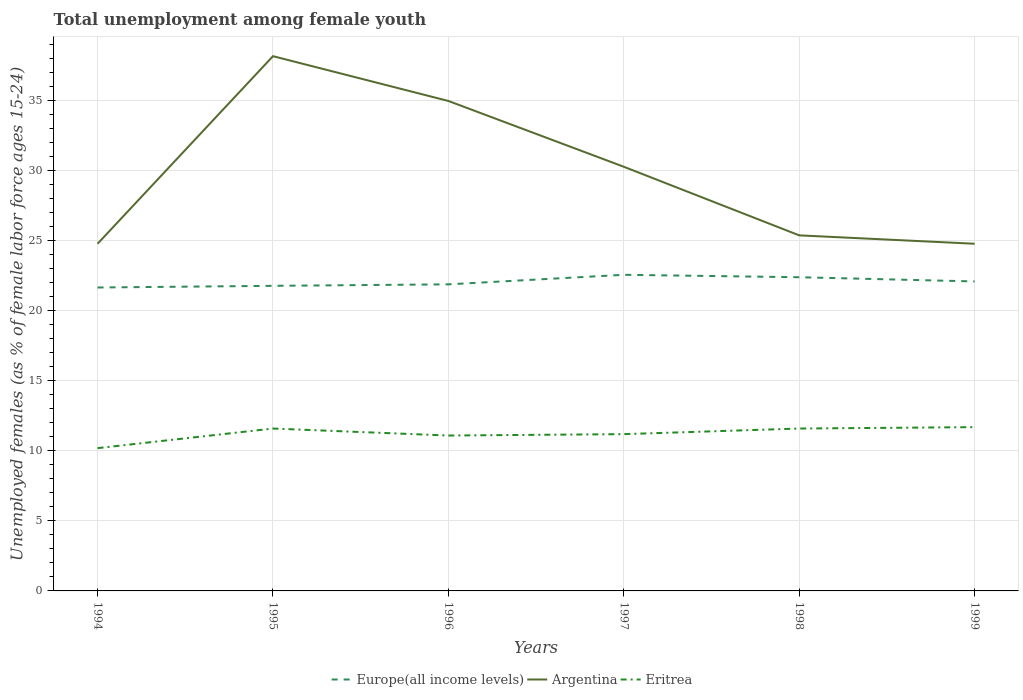Does the line corresponding to Europe(all income levels) intersect with the line corresponding to Eritrea?
Provide a succinct answer. No. Is the number of lines equal to the number of legend labels?
Offer a terse response. Yes. Across all years, what is the maximum percentage of unemployed females in in Europe(all income levels)?
Offer a terse response. 21.68. In which year was the percentage of unemployed females in in Eritrea maximum?
Provide a succinct answer. 1994. What is the total percentage of unemployed females in in Europe(all income levels) in the graph?
Give a very brief answer. -0.31. What is the difference between the highest and the second highest percentage of unemployed females in in Argentina?
Give a very brief answer. 13.4. Is the percentage of unemployed females in in Argentina strictly greater than the percentage of unemployed females in in Eritrea over the years?
Your answer should be compact. No. How many lines are there?
Offer a very short reply. 3. Are the values on the major ticks of Y-axis written in scientific E-notation?
Your response must be concise. No. Does the graph contain any zero values?
Your response must be concise. No. How are the legend labels stacked?
Your answer should be very brief. Horizontal. What is the title of the graph?
Provide a short and direct response. Total unemployment among female youth. What is the label or title of the Y-axis?
Offer a terse response. Unemployed females (as % of female labor force ages 15-24). What is the Unemployed females (as % of female labor force ages 15-24) of Europe(all income levels) in 1994?
Provide a succinct answer. 21.68. What is the Unemployed females (as % of female labor force ages 15-24) in Argentina in 1994?
Your answer should be very brief. 24.8. What is the Unemployed females (as % of female labor force ages 15-24) in Eritrea in 1994?
Provide a succinct answer. 10.2. What is the Unemployed females (as % of female labor force ages 15-24) of Europe(all income levels) in 1995?
Keep it short and to the point. 21.79. What is the Unemployed females (as % of female labor force ages 15-24) of Argentina in 1995?
Your answer should be very brief. 38.2. What is the Unemployed females (as % of female labor force ages 15-24) of Eritrea in 1995?
Keep it short and to the point. 11.6. What is the Unemployed females (as % of female labor force ages 15-24) of Europe(all income levels) in 1996?
Make the answer very short. 21.9. What is the Unemployed females (as % of female labor force ages 15-24) of Eritrea in 1996?
Provide a short and direct response. 11.1. What is the Unemployed females (as % of female labor force ages 15-24) of Europe(all income levels) in 1997?
Your answer should be compact. 22.58. What is the Unemployed females (as % of female labor force ages 15-24) in Argentina in 1997?
Make the answer very short. 30.3. What is the Unemployed females (as % of female labor force ages 15-24) in Eritrea in 1997?
Your answer should be compact. 11.2. What is the Unemployed females (as % of female labor force ages 15-24) of Europe(all income levels) in 1998?
Your answer should be very brief. 22.41. What is the Unemployed females (as % of female labor force ages 15-24) of Argentina in 1998?
Provide a succinct answer. 25.4. What is the Unemployed females (as % of female labor force ages 15-24) in Eritrea in 1998?
Keep it short and to the point. 11.6. What is the Unemployed females (as % of female labor force ages 15-24) of Europe(all income levels) in 1999?
Provide a short and direct response. 22.11. What is the Unemployed females (as % of female labor force ages 15-24) in Argentina in 1999?
Your answer should be compact. 24.8. What is the Unemployed females (as % of female labor force ages 15-24) of Eritrea in 1999?
Give a very brief answer. 11.7. Across all years, what is the maximum Unemployed females (as % of female labor force ages 15-24) in Europe(all income levels)?
Provide a succinct answer. 22.58. Across all years, what is the maximum Unemployed females (as % of female labor force ages 15-24) of Argentina?
Your answer should be compact. 38.2. Across all years, what is the maximum Unemployed females (as % of female labor force ages 15-24) of Eritrea?
Make the answer very short. 11.7. Across all years, what is the minimum Unemployed females (as % of female labor force ages 15-24) of Europe(all income levels)?
Keep it short and to the point. 21.68. Across all years, what is the minimum Unemployed females (as % of female labor force ages 15-24) in Argentina?
Your response must be concise. 24.8. Across all years, what is the minimum Unemployed females (as % of female labor force ages 15-24) of Eritrea?
Your answer should be compact. 10.2. What is the total Unemployed females (as % of female labor force ages 15-24) in Europe(all income levels) in the graph?
Ensure brevity in your answer.  132.47. What is the total Unemployed females (as % of female labor force ages 15-24) in Argentina in the graph?
Ensure brevity in your answer.  178.5. What is the total Unemployed females (as % of female labor force ages 15-24) of Eritrea in the graph?
Your response must be concise. 67.4. What is the difference between the Unemployed females (as % of female labor force ages 15-24) in Europe(all income levels) in 1994 and that in 1995?
Ensure brevity in your answer.  -0.12. What is the difference between the Unemployed females (as % of female labor force ages 15-24) of Europe(all income levels) in 1994 and that in 1996?
Your response must be concise. -0.23. What is the difference between the Unemployed females (as % of female labor force ages 15-24) in Argentina in 1994 and that in 1996?
Your answer should be very brief. -10.2. What is the difference between the Unemployed females (as % of female labor force ages 15-24) in Eritrea in 1994 and that in 1996?
Keep it short and to the point. -0.9. What is the difference between the Unemployed females (as % of female labor force ages 15-24) of Europe(all income levels) in 1994 and that in 1997?
Provide a short and direct response. -0.91. What is the difference between the Unemployed females (as % of female labor force ages 15-24) in Argentina in 1994 and that in 1997?
Your answer should be compact. -5.5. What is the difference between the Unemployed females (as % of female labor force ages 15-24) in Eritrea in 1994 and that in 1997?
Your response must be concise. -1. What is the difference between the Unemployed females (as % of female labor force ages 15-24) of Europe(all income levels) in 1994 and that in 1998?
Offer a very short reply. -0.73. What is the difference between the Unemployed females (as % of female labor force ages 15-24) in Europe(all income levels) in 1994 and that in 1999?
Make the answer very short. -0.43. What is the difference between the Unemployed females (as % of female labor force ages 15-24) in Europe(all income levels) in 1995 and that in 1996?
Provide a short and direct response. -0.11. What is the difference between the Unemployed females (as % of female labor force ages 15-24) of Europe(all income levels) in 1995 and that in 1997?
Your answer should be very brief. -0.79. What is the difference between the Unemployed females (as % of female labor force ages 15-24) in Argentina in 1995 and that in 1997?
Give a very brief answer. 7.9. What is the difference between the Unemployed females (as % of female labor force ages 15-24) of Eritrea in 1995 and that in 1997?
Make the answer very short. 0.4. What is the difference between the Unemployed females (as % of female labor force ages 15-24) of Europe(all income levels) in 1995 and that in 1998?
Provide a succinct answer. -0.61. What is the difference between the Unemployed females (as % of female labor force ages 15-24) of Argentina in 1995 and that in 1998?
Provide a short and direct response. 12.8. What is the difference between the Unemployed females (as % of female labor force ages 15-24) in Eritrea in 1995 and that in 1998?
Your answer should be compact. 0. What is the difference between the Unemployed females (as % of female labor force ages 15-24) in Europe(all income levels) in 1995 and that in 1999?
Your response must be concise. -0.31. What is the difference between the Unemployed females (as % of female labor force ages 15-24) in Argentina in 1995 and that in 1999?
Offer a very short reply. 13.4. What is the difference between the Unemployed females (as % of female labor force ages 15-24) of Europe(all income levels) in 1996 and that in 1997?
Ensure brevity in your answer.  -0.68. What is the difference between the Unemployed females (as % of female labor force ages 15-24) in Argentina in 1996 and that in 1997?
Offer a terse response. 4.7. What is the difference between the Unemployed females (as % of female labor force ages 15-24) in Europe(all income levels) in 1996 and that in 1998?
Make the answer very short. -0.51. What is the difference between the Unemployed females (as % of female labor force ages 15-24) of Argentina in 1996 and that in 1998?
Provide a short and direct response. 9.6. What is the difference between the Unemployed females (as % of female labor force ages 15-24) in Europe(all income levels) in 1996 and that in 1999?
Keep it short and to the point. -0.21. What is the difference between the Unemployed females (as % of female labor force ages 15-24) of Eritrea in 1996 and that in 1999?
Provide a short and direct response. -0.6. What is the difference between the Unemployed females (as % of female labor force ages 15-24) of Europe(all income levels) in 1997 and that in 1998?
Your response must be concise. 0.17. What is the difference between the Unemployed females (as % of female labor force ages 15-24) of Argentina in 1997 and that in 1998?
Offer a terse response. 4.9. What is the difference between the Unemployed females (as % of female labor force ages 15-24) in Europe(all income levels) in 1997 and that in 1999?
Offer a very short reply. 0.47. What is the difference between the Unemployed females (as % of female labor force ages 15-24) in Argentina in 1997 and that in 1999?
Make the answer very short. 5.5. What is the difference between the Unemployed females (as % of female labor force ages 15-24) of Eritrea in 1997 and that in 1999?
Provide a succinct answer. -0.5. What is the difference between the Unemployed females (as % of female labor force ages 15-24) of Europe(all income levels) in 1998 and that in 1999?
Your answer should be very brief. 0.3. What is the difference between the Unemployed females (as % of female labor force ages 15-24) in Europe(all income levels) in 1994 and the Unemployed females (as % of female labor force ages 15-24) in Argentina in 1995?
Offer a terse response. -16.52. What is the difference between the Unemployed females (as % of female labor force ages 15-24) in Europe(all income levels) in 1994 and the Unemployed females (as % of female labor force ages 15-24) in Eritrea in 1995?
Your response must be concise. 10.08. What is the difference between the Unemployed females (as % of female labor force ages 15-24) of Argentina in 1994 and the Unemployed females (as % of female labor force ages 15-24) of Eritrea in 1995?
Make the answer very short. 13.2. What is the difference between the Unemployed females (as % of female labor force ages 15-24) of Europe(all income levels) in 1994 and the Unemployed females (as % of female labor force ages 15-24) of Argentina in 1996?
Your answer should be very brief. -13.32. What is the difference between the Unemployed females (as % of female labor force ages 15-24) of Europe(all income levels) in 1994 and the Unemployed females (as % of female labor force ages 15-24) of Eritrea in 1996?
Keep it short and to the point. 10.58. What is the difference between the Unemployed females (as % of female labor force ages 15-24) in Argentina in 1994 and the Unemployed females (as % of female labor force ages 15-24) in Eritrea in 1996?
Your response must be concise. 13.7. What is the difference between the Unemployed females (as % of female labor force ages 15-24) of Europe(all income levels) in 1994 and the Unemployed females (as % of female labor force ages 15-24) of Argentina in 1997?
Make the answer very short. -8.62. What is the difference between the Unemployed females (as % of female labor force ages 15-24) of Europe(all income levels) in 1994 and the Unemployed females (as % of female labor force ages 15-24) of Eritrea in 1997?
Ensure brevity in your answer.  10.48. What is the difference between the Unemployed females (as % of female labor force ages 15-24) of Europe(all income levels) in 1994 and the Unemployed females (as % of female labor force ages 15-24) of Argentina in 1998?
Keep it short and to the point. -3.72. What is the difference between the Unemployed females (as % of female labor force ages 15-24) of Europe(all income levels) in 1994 and the Unemployed females (as % of female labor force ages 15-24) of Eritrea in 1998?
Provide a succinct answer. 10.08. What is the difference between the Unemployed females (as % of female labor force ages 15-24) in Argentina in 1994 and the Unemployed females (as % of female labor force ages 15-24) in Eritrea in 1998?
Ensure brevity in your answer.  13.2. What is the difference between the Unemployed females (as % of female labor force ages 15-24) of Europe(all income levels) in 1994 and the Unemployed females (as % of female labor force ages 15-24) of Argentina in 1999?
Provide a succinct answer. -3.12. What is the difference between the Unemployed females (as % of female labor force ages 15-24) of Europe(all income levels) in 1994 and the Unemployed females (as % of female labor force ages 15-24) of Eritrea in 1999?
Make the answer very short. 9.98. What is the difference between the Unemployed females (as % of female labor force ages 15-24) of Europe(all income levels) in 1995 and the Unemployed females (as % of female labor force ages 15-24) of Argentina in 1996?
Keep it short and to the point. -13.21. What is the difference between the Unemployed females (as % of female labor force ages 15-24) in Europe(all income levels) in 1995 and the Unemployed females (as % of female labor force ages 15-24) in Eritrea in 1996?
Your answer should be very brief. 10.69. What is the difference between the Unemployed females (as % of female labor force ages 15-24) in Argentina in 1995 and the Unemployed females (as % of female labor force ages 15-24) in Eritrea in 1996?
Provide a short and direct response. 27.1. What is the difference between the Unemployed females (as % of female labor force ages 15-24) of Europe(all income levels) in 1995 and the Unemployed females (as % of female labor force ages 15-24) of Argentina in 1997?
Offer a very short reply. -8.51. What is the difference between the Unemployed females (as % of female labor force ages 15-24) in Europe(all income levels) in 1995 and the Unemployed females (as % of female labor force ages 15-24) in Eritrea in 1997?
Your answer should be very brief. 10.59. What is the difference between the Unemployed females (as % of female labor force ages 15-24) in Argentina in 1995 and the Unemployed females (as % of female labor force ages 15-24) in Eritrea in 1997?
Your response must be concise. 27. What is the difference between the Unemployed females (as % of female labor force ages 15-24) of Europe(all income levels) in 1995 and the Unemployed females (as % of female labor force ages 15-24) of Argentina in 1998?
Ensure brevity in your answer.  -3.61. What is the difference between the Unemployed females (as % of female labor force ages 15-24) in Europe(all income levels) in 1995 and the Unemployed females (as % of female labor force ages 15-24) in Eritrea in 1998?
Ensure brevity in your answer.  10.19. What is the difference between the Unemployed females (as % of female labor force ages 15-24) of Argentina in 1995 and the Unemployed females (as % of female labor force ages 15-24) of Eritrea in 1998?
Your answer should be very brief. 26.6. What is the difference between the Unemployed females (as % of female labor force ages 15-24) in Europe(all income levels) in 1995 and the Unemployed females (as % of female labor force ages 15-24) in Argentina in 1999?
Offer a very short reply. -3.01. What is the difference between the Unemployed females (as % of female labor force ages 15-24) of Europe(all income levels) in 1995 and the Unemployed females (as % of female labor force ages 15-24) of Eritrea in 1999?
Keep it short and to the point. 10.09. What is the difference between the Unemployed females (as % of female labor force ages 15-24) in Europe(all income levels) in 1996 and the Unemployed females (as % of female labor force ages 15-24) in Argentina in 1997?
Ensure brevity in your answer.  -8.4. What is the difference between the Unemployed females (as % of female labor force ages 15-24) in Europe(all income levels) in 1996 and the Unemployed females (as % of female labor force ages 15-24) in Eritrea in 1997?
Make the answer very short. 10.7. What is the difference between the Unemployed females (as % of female labor force ages 15-24) in Argentina in 1996 and the Unemployed females (as % of female labor force ages 15-24) in Eritrea in 1997?
Offer a very short reply. 23.8. What is the difference between the Unemployed females (as % of female labor force ages 15-24) of Europe(all income levels) in 1996 and the Unemployed females (as % of female labor force ages 15-24) of Argentina in 1998?
Provide a short and direct response. -3.5. What is the difference between the Unemployed females (as % of female labor force ages 15-24) of Europe(all income levels) in 1996 and the Unemployed females (as % of female labor force ages 15-24) of Eritrea in 1998?
Your response must be concise. 10.3. What is the difference between the Unemployed females (as % of female labor force ages 15-24) in Argentina in 1996 and the Unemployed females (as % of female labor force ages 15-24) in Eritrea in 1998?
Provide a short and direct response. 23.4. What is the difference between the Unemployed females (as % of female labor force ages 15-24) of Europe(all income levels) in 1996 and the Unemployed females (as % of female labor force ages 15-24) of Argentina in 1999?
Keep it short and to the point. -2.9. What is the difference between the Unemployed females (as % of female labor force ages 15-24) of Europe(all income levels) in 1996 and the Unemployed females (as % of female labor force ages 15-24) of Eritrea in 1999?
Keep it short and to the point. 10.2. What is the difference between the Unemployed females (as % of female labor force ages 15-24) of Argentina in 1996 and the Unemployed females (as % of female labor force ages 15-24) of Eritrea in 1999?
Ensure brevity in your answer.  23.3. What is the difference between the Unemployed females (as % of female labor force ages 15-24) in Europe(all income levels) in 1997 and the Unemployed females (as % of female labor force ages 15-24) in Argentina in 1998?
Make the answer very short. -2.82. What is the difference between the Unemployed females (as % of female labor force ages 15-24) of Europe(all income levels) in 1997 and the Unemployed females (as % of female labor force ages 15-24) of Eritrea in 1998?
Your answer should be compact. 10.98. What is the difference between the Unemployed females (as % of female labor force ages 15-24) in Europe(all income levels) in 1997 and the Unemployed females (as % of female labor force ages 15-24) in Argentina in 1999?
Your response must be concise. -2.22. What is the difference between the Unemployed females (as % of female labor force ages 15-24) of Europe(all income levels) in 1997 and the Unemployed females (as % of female labor force ages 15-24) of Eritrea in 1999?
Offer a very short reply. 10.88. What is the difference between the Unemployed females (as % of female labor force ages 15-24) of Europe(all income levels) in 1998 and the Unemployed females (as % of female labor force ages 15-24) of Argentina in 1999?
Your answer should be very brief. -2.39. What is the difference between the Unemployed females (as % of female labor force ages 15-24) of Europe(all income levels) in 1998 and the Unemployed females (as % of female labor force ages 15-24) of Eritrea in 1999?
Ensure brevity in your answer.  10.71. What is the difference between the Unemployed females (as % of female labor force ages 15-24) in Argentina in 1998 and the Unemployed females (as % of female labor force ages 15-24) in Eritrea in 1999?
Ensure brevity in your answer.  13.7. What is the average Unemployed females (as % of female labor force ages 15-24) of Europe(all income levels) per year?
Your answer should be very brief. 22.08. What is the average Unemployed females (as % of female labor force ages 15-24) of Argentina per year?
Give a very brief answer. 29.75. What is the average Unemployed females (as % of female labor force ages 15-24) in Eritrea per year?
Provide a succinct answer. 11.23. In the year 1994, what is the difference between the Unemployed females (as % of female labor force ages 15-24) of Europe(all income levels) and Unemployed females (as % of female labor force ages 15-24) of Argentina?
Offer a very short reply. -3.12. In the year 1994, what is the difference between the Unemployed females (as % of female labor force ages 15-24) in Europe(all income levels) and Unemployed females (as % of female labor force ages 15-24) in Eritrea?
Offer a very short reply. 11.48. In the year 1995, what is the difference between the Unemployed females (as % of female labor force ages 15-24) of Europe(all income levels) and Unemployed females (as % of female labor force ages 15-24) of Argentina?
Make the answer very short. -16.41. In the year 1995, what is the difference between the Unemployed females (as % of female labor force ages 15-24) of Europe(all income levels) and Unemployed females (as % of female labor force ages 15-24) of Eritrea?
Offer a very short reply. 10.19. In the year 1995, what is the difference between the Unemployed females (as % of female labor force ages 15-24) in Argentina and Unemployed females (as % of female labor force ages 15-24) in Eritrea?
Your answer should be very brief. 26.6. In the year 1996, what is the difference between the Unemployed females (as % of female labor force ages 15-24) in Europe(all income levels) and Unemployed females (as % of female labor force ages 15-24) in Argentina?
Your response must be concise. -13.1. In the year 1996, what is the difference between the Unemployed females (as % of female labor force ages 15-24) of Europe(all income levels) and Unemployed females (as % of female labor force ages 15-24) of Eritrea?
Offer a very short reply. 10.8. In the year 1996, what is the difference between the Unemployed females (as % of female labor force ages 15-24) in Argentina and Unemployed females (as % of female labor force ages 15-24) in Eritrea?
Your answer should be very brief. 23.9. In the year 1997, what is the difference between the Unemployed females (as % of female labor force ages 15-24) of Europe(all income levels) and Unemployed females (as % of female labor force ages 15-24) of Argentina?
Offer a terse response. -7.72. In the year 1997, what is the difference between the Unemployed females (as % of female labor force ages 15-24) of Europe(all income levels) and Unemployed females (as % of female labor force ages 15-24) of Eritrea?
Ensure brevity in your answer.  11.38. In the year 1998, what is the difference between the Unemployed females (as % of female labor force ages 15-24) in Europe(all income levels) and Unemployed females (as % of female labor force ages 15-24) in Argentina?
Your answer should be compact. -2.99. In the year 1998, what is the difference between the Unemployed females (as % of female labor force ages 15-24) in Europe(all income levels) and Unemployed females (as % of female labor force ages 15-24) in Eritrea?
Ensure brevity in your answer.  10.81. In the year 1999, what is the difference between the Unemployed females (as % of female labor force ages 15-24) of Europe(all income levels) and Unemployed females (as % of female labor force ages 15-24) of Argentina?
Your answer should be very brief. -2.69. In the year 1999, what is the difference between the Unemployed females (as % of female labor force ages 15-24) in Europe(all income levels) and Unemployed females (as % of female labor force ages 15-24) in Eritrea?
Your response must be concise. 10.41. What is the ratio of the Unemployed females (as % of female labor force ages 15-24) of Europe(all income levels) in 1994 to that in 1995?
Your answer should be compact. 0.99. What is the ratio of the Unemployed females (as % of female labor force ages 15-24) in Argentina in 1994 to that in 1995?
Offer a very short reply. 0.65. What is the ratio of the Unemployed females (as % of female labor force ages 15-24) of Eritrea in 1994 to that in 1995?
Keep it short and to the point. 0.88. What is the ratio of the Unemployed females (as % of female labor force ages 15-24) of Argentina in 1994 to that in 1996?
Provide a succinct answer. 0.71. What is the ratio of the Unemployed females (as % of female labor force ages 15-24) in Eritrea in 1994 to that in 1996?
Your response must be concise. 0.92. What is the ratio of the Unemployed females (as % of female labor force ages 15-24) in Europe(all income levels) in 1994 to that in 1997?
Your answer should be compact. 0.96. What is the ratio of the Unemployed females (as % of female labor force ages 15-24) of Argentina in 1994 to that in 1997?
Provide a short and direct response. 0.82. What is the ratio of the Unemployed females (as % of female labor force ages 15-24) of Eritrea in 1994 to that in 1997?
Offer a very short reply. 0.91. What is the ratio of the Unemployed females (as % of female labor force ages 15-24) in Europe(all income levels) in 1994 to that in 1998?
Keep it short and to the point. 0.97. What is the ratio of the Unemployed females (as % of female labor force ages 15-24) in Argentina in 1994 to that in 1998?
Offer a terse response. 0.98. What is the ratio of the Unemployed females (as % of female labor force ages 15-24) of Eritrea in 1994 to that in 1998?
Your answer should be very brief. 0.88. What is the ratio of the Unemployed females (as % of female labor force ages 15-24) in Europe(all income levels) in 1994 to that in 1999?
Your response must be concise. 0.98. What is the ratio of the Unemployed females (as % of female labor force ages 15-24) of Argentina in 1994 to that in 1999?
Give a very brief answer. 1. What is the ratio of the Unemployed females (as % of female labor force ages 15-24) of Eritrea in 1994 to that in 1999?
Make the answer very short. 0.87. What is the ratio of the Unemployed females (as % of female labor force ages 15-24) of Europe(all income levels) in 1995 to that in 1996?
Provide a short and direct response. 1. What is the ratio of the Unemployed females (as % of female labor force ages 15-24) of Argentina in 1995 to that in 1996?
Your answer should be compact. 1.09. What is the ratio of the Unemployed females (as % of female labor force ages 15-24) in Eritrea in 1995 to that in 1996?
Offer a terse response. 1.04. What is the ratio of the Unemployed females (as % of female labor force ages 15-24) of Europe(all income levels) in 1995 to that in 1997?
Provide a succinct answer. 0.97. What is the ratio of the Unemployed females (as % of female labor force ages 15-24) in Argentina in 1995 to that in 1997?
Provide a short and direct response. 1.26. What is the ratio of the Unemployed females (as % of female labor force ages 15-24) of Eritrea in 1995 to that in 1997?
Keep it short and to the point. 1.04. What is the ratio of the Unemployed females (as % of female labor force ages 15-24) of Europe(all income levels) in 1995 to that in 1998?
Ensure brevity in your answer.  0.97. What is the ratio of the Unemployed females (as % of female labor force ages 15-24) in Argentina in 1995 to that in 1998?
Offer a terse response. 1.5. What is the ratio of the Unemployed females (as % of female labor force ages 15-24) of Europe(all income levels) in 1995 to that in 1999?
Ensure brevity in your answer.  0.99. What is the ratio of the Unemployed females (as % of female labor force ages 15-24) in Argentina in 1995 to that in 1999?
Your response must be concise. 1.54. What is the ratio of the Unemployed females (as % of female labor force ages 15-24) of Europe(all income levels) in 1996 to that in 1997?
Make the answer very short. 0.97. What is the ratio of the Unemployed females (as % of female labor force ages 15-24) in Argentina in 1996 to that in 1997?
Your answer should be very brief. 1.16. What is the ratio of the Unemployed females (as % of female labor force ages 15-24) of Europe(all income levels) in 1996 to that in 1998?
Offer a terse response. 0.98. What is the ratio of the Unemployed females (as % of female labor force ages 15-24) of Argentina in 1996 to that in 1998?
Your answer should be compact. 1.38. What is the ratio of the Unemployed females (as % of female labor force ages 15-24) in Eritrea in 1996 to that in 1998?
Make the answer very short. 0.96. What is the ratio of the Unemployed females (as % of female labor force ages 15-24) of Europe(all income levels) in 1996 to that in 1999?
Keep it short and to the point. 0.99. What is the ratio of the Unemployed females (as % of female labor force ages 15-24) of Argentina in 1996 to that in 1999?
Give a very brief answer. 1.41. What is the ratio of the Unemployed females (as % of female labor force ages 15-24) in Eritrea in 1996 to that in 1999?
Your answer should be very brief. 0.95. What is the ratio of the Unemployed females (as % of female labor force ages 15-24) in Europe(all income levels) in 1997 to that in 1998?
Your answer should be very brief. 1.01. What is the ratio of the Unemployed females (as % of female labor force ages 15-24) in Argentina in 1997 to that in 1998?
Give a very brief answer. 1.19. What is the ratio of the Unemployed females (as % of female labor force ages 15-24) of Eritrea in 1997 to that in 1998?
Offer a very short reply. 0.97. What is the ratio of the Unemployed females (as % of female labor force ages 15-24) in Europe(all income levels) in 1997 to that in 1999?
Your answer should be compact. 1.02. What is the ratio of the Unemployed females (as % of female labor force ages 15-24) of Argentina in 1997 to that in 1999?
Your answer should be compact. 1.22. What is the ratio of the Unemployed females (as % of female labor force ages 15-24) in Eritrea in 1997 to that in 1999?
Your answer should be compact. 0.96. What is the ratio of the Unemployed females (as % of female labor force ages 15-24) of Europe(all income levels) in 1998 to that in 1999?
Your answer should be compact. 1.01. What is the ratio of the Unemployed females (as % of female labor force ages 15-24) in Argentina in 1998 to that in 1999?
Your answer should be compact. 1.02. What is the difference between the highest and the second highest Unemployed females (as % of female labor force ages 15-24) of Europe(all income levels)?
Offer a terse response. 0.17. What is the difference between the highest and the second highest Unemployed females (as % of female labor force ages 15-24) in Argentina?
Make the answer very short. 3.2. What is the difference between the highest and the lowest Unemployed females (as % of female labor force ages 15-24) in Europe(all income levels)?
Ensure brevity in your answer.  0.91. What is the difference between the highest and the lowest Unemployed females (as % of female labor force ages 15-24) of Eritrea?
Provide a short and direct response. 1.5. 